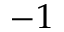Convert formula to latex. <formula><loc_0><loc_0><loc_500><loc_500>- 1</formula> 